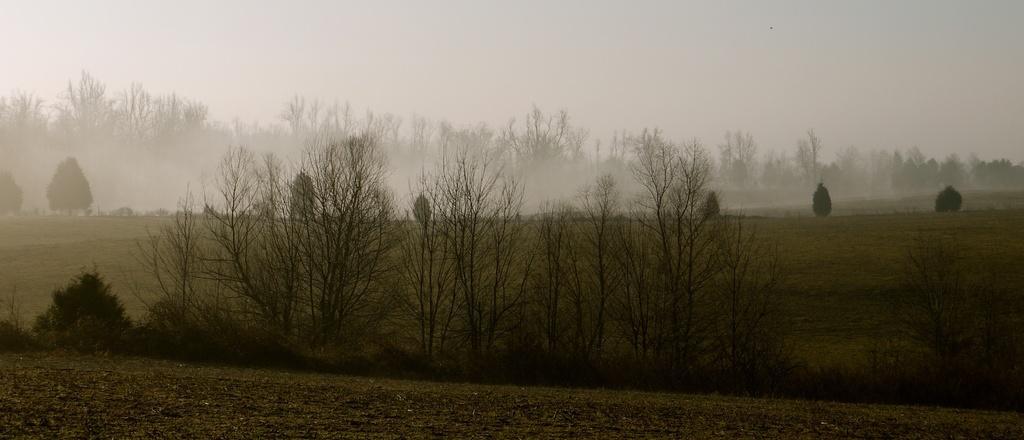Describe this image in one or two sentences. In this image we can see some trees and in the background, we can see the sky. 